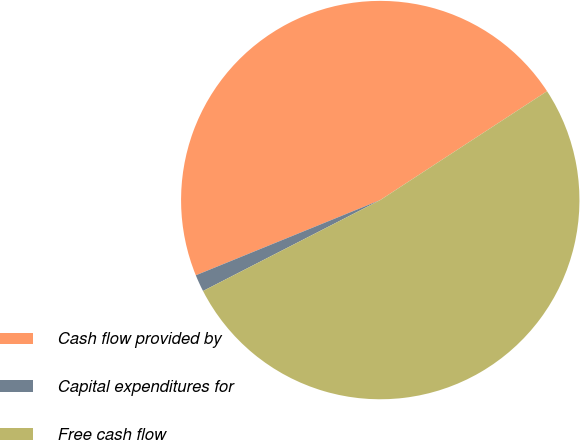Convert chart to OTSL. <chart><loc_0><loc_0><loc_500><loc_500><pie_chart><fcel>Cash flow provided by<fcel>Capital expenditures for<fcel>Free cash flow<nl><fcel>46.96%<fcel>1.38%<fcel>51.66%<nl></chart> 